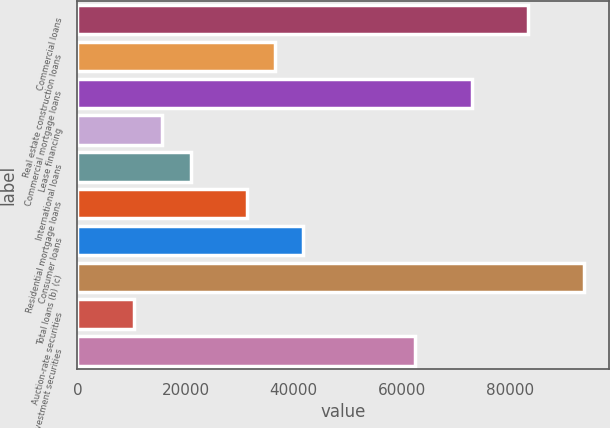Convert chart to OTSL. <chart><loc_0><loc_0><loc_500><loc_500><bar_chart><fcel>Commercial loans<fcel>Real estate construction loans<fcel>Commercial mortgage loans<fcel>Lease financing<fcel>International loans<fcel>Residential mortgage loans<fcel>Consumer loans<fcel>Total loans (b) (c)<fcel>Auction-rate securities<fcel>Other investment securities<nl><fcel>83316.2<fcel>36523.4<fcel>72917.8<fcel>15726.6<fcel>20925.8<fcel>31324.2<fcel>41722.6<fcel>93714.6<fcel>10527.4<fcel>62519.4<nl></chart> 